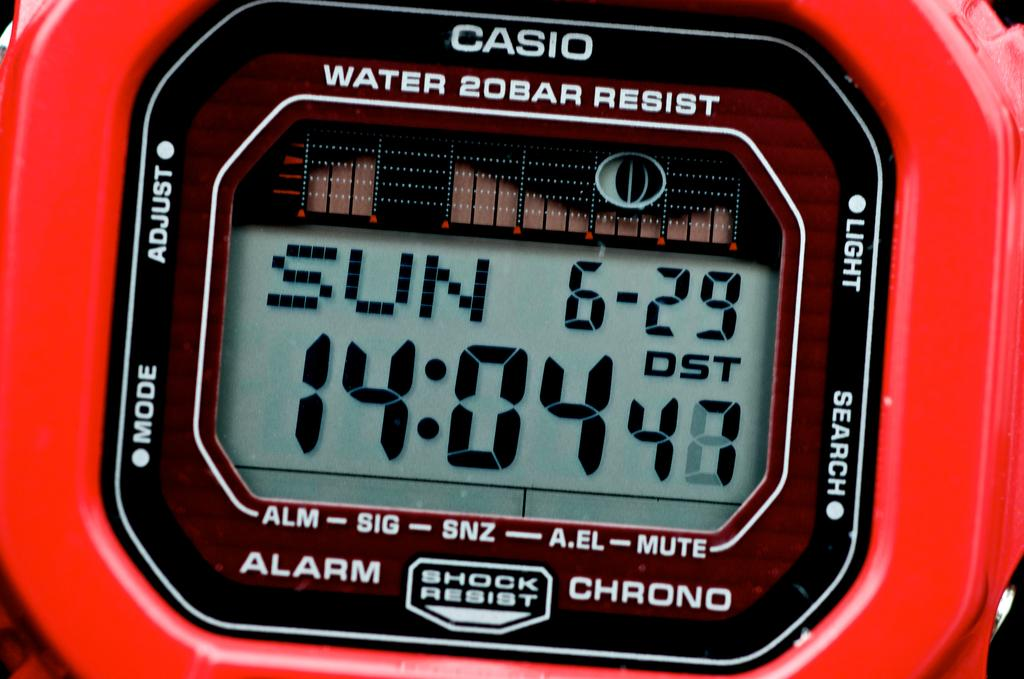Provide a one-sentence caption for the provided image. A casio watch with the time 14:04 on it. 